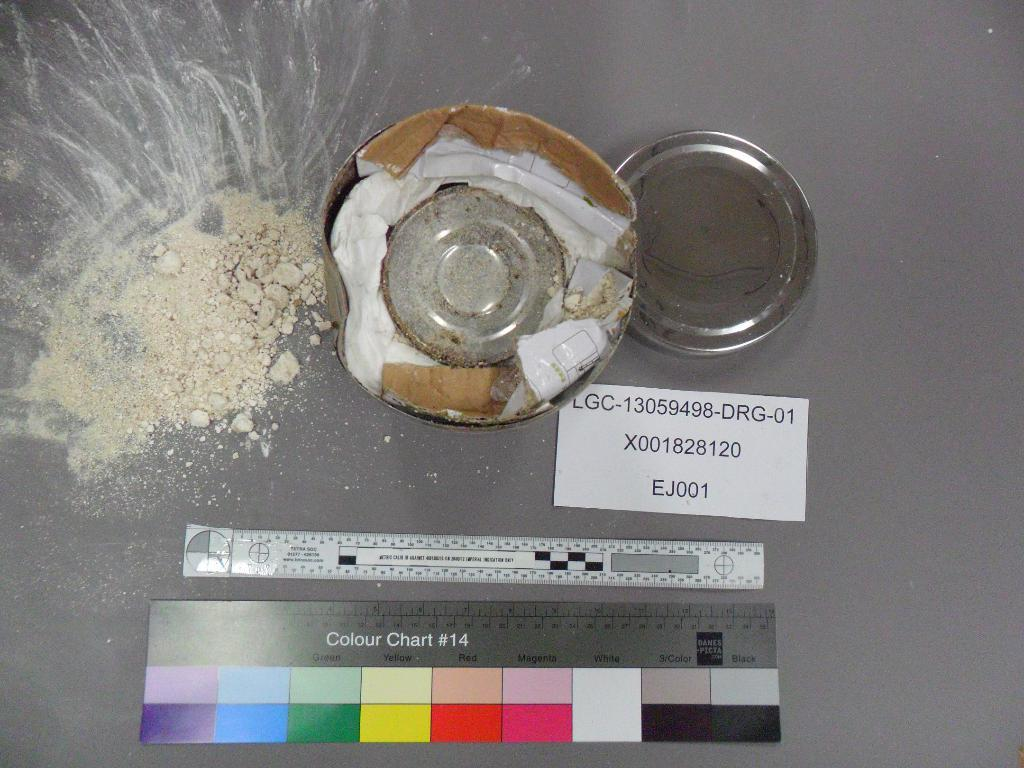Provide a one-sentence caption for the provided image. A white powdery substance that is all over and underneath it is a colour chart with various colors. 